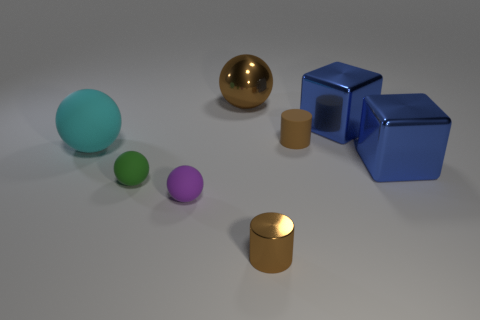What number of things are left of the brown metallic cylinder and behind the large matte object?
Your response must be concise. 1. What number of other things are there of the same shape as the brown rubber object?
Make the answer very short. 1. Are there more big metallic objects to the left of the rubber cylinder than small green spheres?
Ensure brevity in your answer.  No. What is the color of the large metallic object on the left side of the small brown shiny cylinder?
Ensure brevity in your answer.  Brown. What is the size of the shiny cylinder that is the same color as the shiny sphere?
Ensure brevity in your answer.  Small. How many rubber objects are either large objects or green spheres?
Your response must be concise. 2. Are there any small matte things that are right of the small rubber object on the right side of the cylinder in front of the cyan rubber ball?
Offer a terse response. No. What number of large spheres are in front of the purple rubber sphere?
Provide a short and direct response. 0. There is another small cylinder that is the same color as the matte cylinder; what is it made of?
Your answer should be compact. Metal. How many large objects are red metallic spheres or spheres?
Ensure brevity in your answer.  2. 